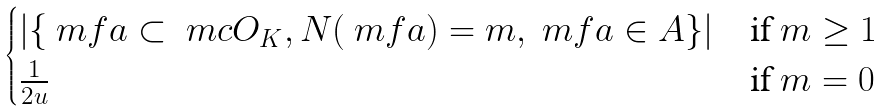Convert formula to latex. <formula><loc_0><loc_0><loc_500><loc_500>\begin{cases} | \{ \ m f a \subset \ m c O _ { K } , N ( \ m f a ) = m , \ m f a \in A \} | & \text {if } m \geq 1 \\ \frac { 1 } { 2 u } & \text {if } m = 0 \end{cases}</formula> 